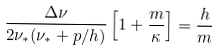Convert formula to latex. <formula><loc_0><loc_0><loc_500><loc_500>\frac { \Delta \nu } { 2 \nu _ { * } ( \nu _ { * } + p / h ) } \left [ 1 + \frac { m } { \kappa } \right ] = \frac { h } { m }</formula> 